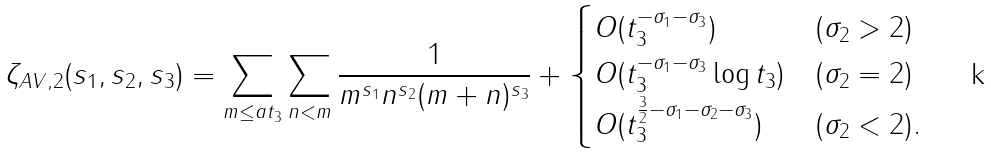<formula> <loc_0><loc_0><loc_500><loc_500>\zeta _ { A V , 2 } ( s _ { 1 } , s _ { 2 } , s _ { 3 } ) & = \sum _ { m \leq a t _ { 3 } } \sum _ { n < m } \frac { 1 } { m ^ { s _ { 1 } } n ^ { s _ { 2 } } ( m + n ) ^ { s _ { 3 } } } + \begin{cases} O ( t _ { 3 } ^ { - \sigma _ { 1 } - \sigma _ { 3 } } ) & ( \sigma _ { 2 } > 2 ) \\ O ( t _ { 3 } ^ { - \sigma _ { 1 } - \sigma _ { 3 } } \log t _ { 3 } ) & ( \sigma _ { 2 } = 2 ) \\ O ( t _ { 3 } ^ { \frac { 3 } { 2 } - \sigma _ { 1 } - \sigma _ { 2 } - \sigma _ { 3 } } ) & ( \sigma _ { 2 } < 2 ) . \\ \end{cases}</formula> 